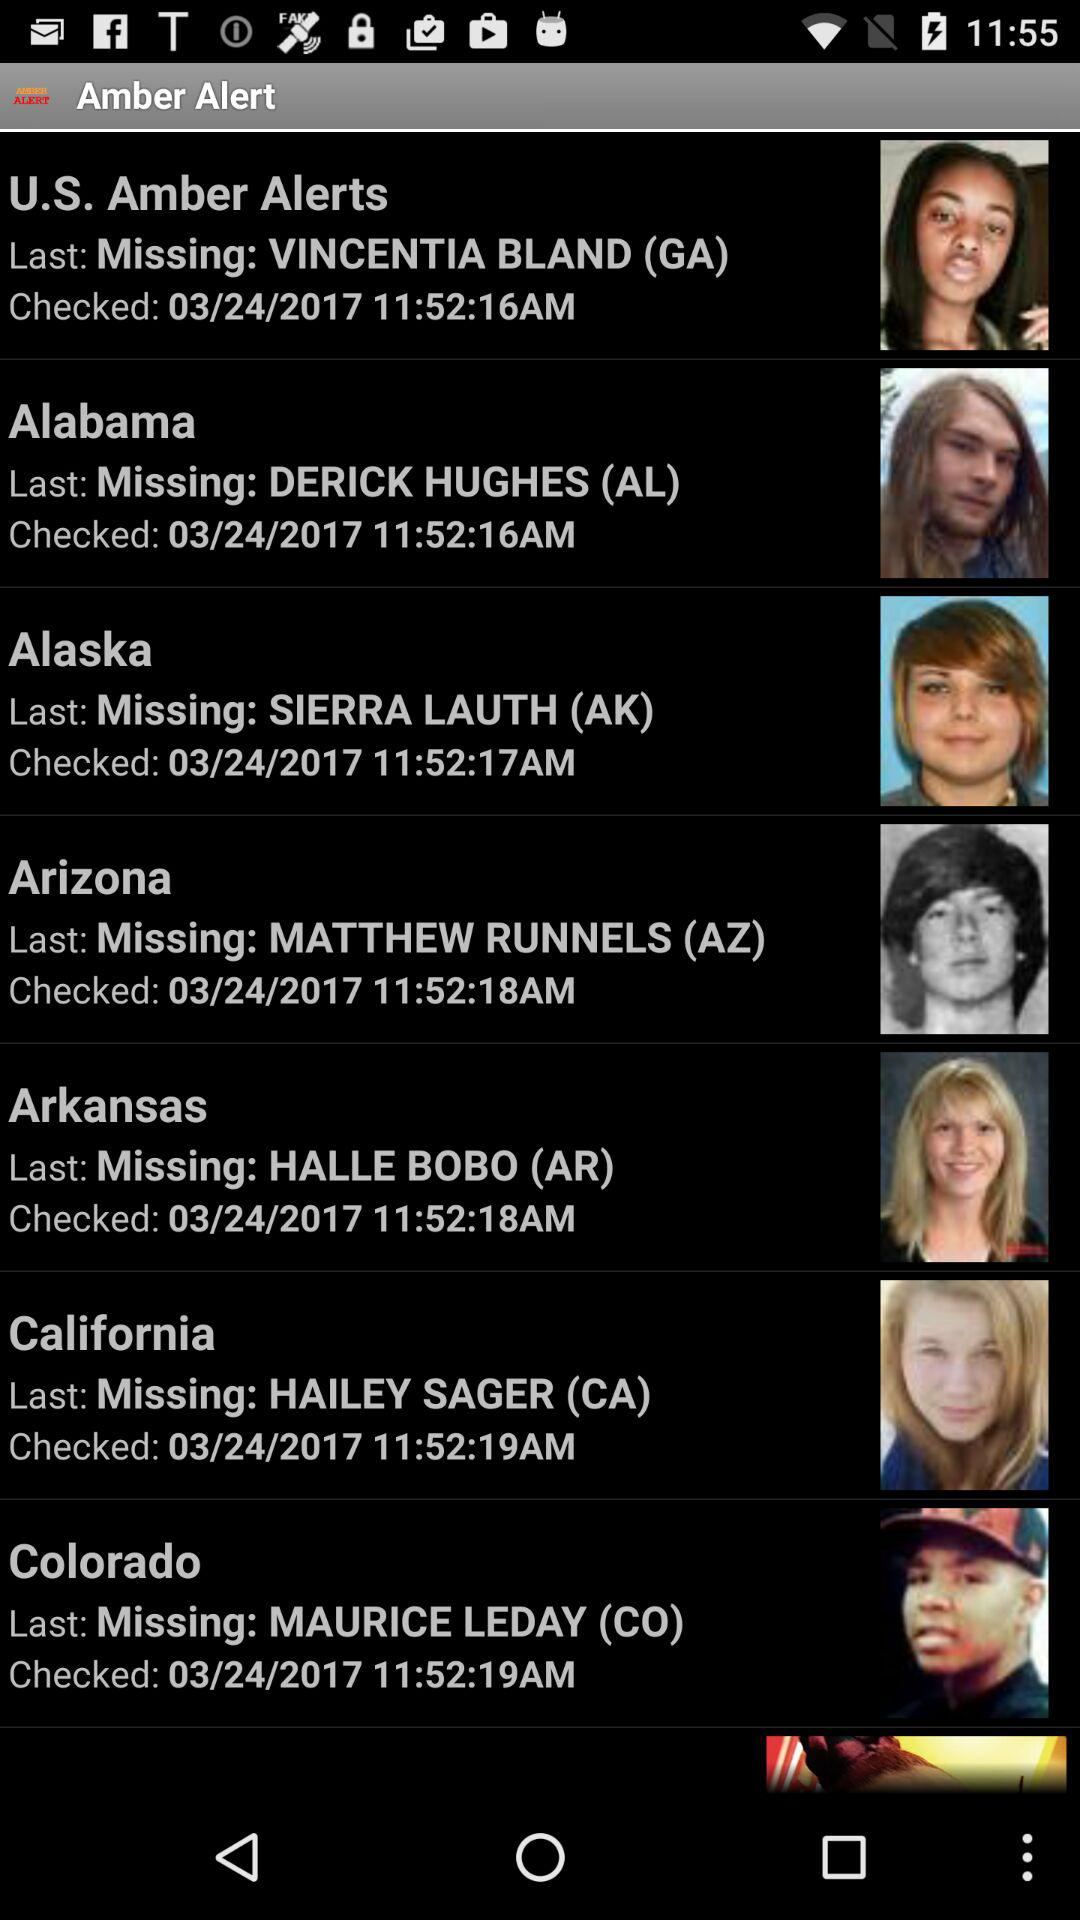Where does Maurice Leday live? Maurice Leday lives in Colorado. 